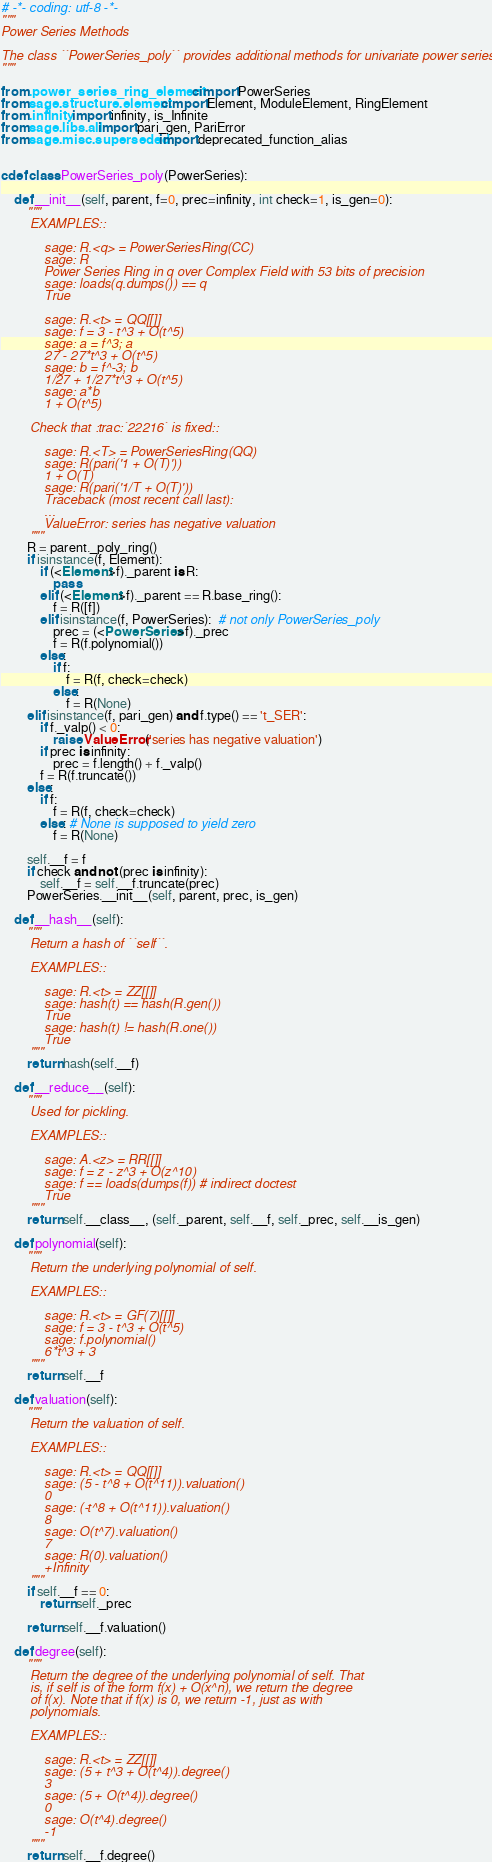Convert code to text. <code><loc_0><loc_0><loc_500><loc_500><_Cython_># -*- coding: utf-8 -*-
"""
Power Series Methods

The class ``PowerSeries_poly`` provides additional methods for univariate power series.
"""

from .power_series_ring_element cimport PowerSeries
from sage.structure.element cimport Element, ModuleElement, RingElement
from .infinity import infinity, is_Infinite
from sage.libs.all import pari_gen, PariError
from sage.misc.superseded import deprecated_function_alias


cdef class PowerSeries_poly(PowerSeries):

    def __init__(self, parent, f=0, prec=infinity, int check=1, is_gen=0):
        """
        EXAMPLES::

            sage: R.<q> = PowerSeriesRing(CC)
            sage: R
            Power Series Ring in q over Complex Field with 53 bits of precision
            sage: loads(q.dumps()) == q
            True

            sage: R.<t> = QQ[[]]
            sage: f = 3 - t^3 + O(t^5)
            sage: a = f^3; a
            27 - 27*t^3 + O(t^5)
            sage: b = f^-3; b
            1/27 + 1/27*t^3 + O(t^5)
            sage: a*b
            1 + O(t^5)

        Check that :trac:`22216` is fixed::

            sage: R.<T> = PowerSeriesRing(QQ)
            sage: R(pari('1 + O(T)'))
            1 + O(T)
            sage: R(pari('1/T + O(T)'))
            Traceback (most recent call last):
            ...
            ValueError: series has negative valuation
        """
        R = parent._poly_ring()
        if isinstance(f, Element):
            if (<Element>f)._parent is R:
                pass
            elif (<Element>f)._parent == R.base_ring():
                f = R([f])
            elif isinstance(f, PowerSeries):  # not only PowerSeries_poly
                prec = (<PowerSeries>f)._prec
                f = R(f.polynomial())
            else:
                if f:
                    f = R(f, check=check)
                else:
                    f = R(None)
        elif isinstance(f, pari_gen) and f.type() == 't_SER':
            if f._valp() < 0:
                raise ValueError('series has negative valuation')
            if prec is infinity:
                prec = f.length() + f._valp()
            f = R(f.truncate())
        else:
            if f:
                f = R(f, check=check)
            else: # None is supposed to yield zero
                f = R(None)

        self.__f = f
        if check and not (prec is infinity):
            self.__f = self.__f.truncate(prec)
        PowerSeries.__init__(self, parent, prec, is_gen)

    def __hash__(self):
        """
        Return a hash of ``self``.

        EXAMPLES::

            sage: R.<t> = ZZ[[]]
            sage: hash(t) == hash(R.gen())
            True
            sage: hash(t) != hash(R.one())
            True
        """
        return hash(self.__f)

    def __reduce__(self):
        """
        Used for pickling.

        EXAMPLES::

            sage: A.<z> = RR[[]]
            sage: f = z - z^3 + O(z^10)
            sage: f == loads(dumps(f)) # indirect doctest
            True
        """
        return self.__class__, (self._parent, self.__f, self._prec, self.__is_gen)

    def polynomial(self):
        """
        Return the underlying polynomial of self.

        EXAMPLES::

            sage: R.<t> = GF(7)[[]]
            sage: f = 3 - t^3 + O(t^5)
            sage: f.polynomial()
            6*t^3 + 3
        """
        return self.__f

    def valuation(self):
        """
        Return the valuation of self.

        EXAMPLES::

            sage: R.<t> = QQ[[]]
            sage: (5 - t^8 + O(t^11)).valuation()
            0
            sage: (-t^8 + O(t^11)).valuation()
            8
            sage: O(t^7).valuation()
            7
            sage: R(0).valuation()
            +Infinity
        """
        if self.__f == 0:
            return self._prec

        return self.__f.valuation()

    def degree(self):
        """
        Return the degree of the underlying polynomial of self. That
        is, if self is of the form f(x) + O(x^n), we return the degree
        of f(x). Note that if f(x) is 0, we return -1, just as with
        polynomials.

        EXAMPLES::

            sage: R.<t> = ZZ[[]]
            sage: (5 + t^3 + O(t^4)).degree()
            3
            sage: (5 + O(t^4)).degree()
            0
            sage: O(t^4).degree()
            -1
        """
        return self.__f.degree()
</code> 